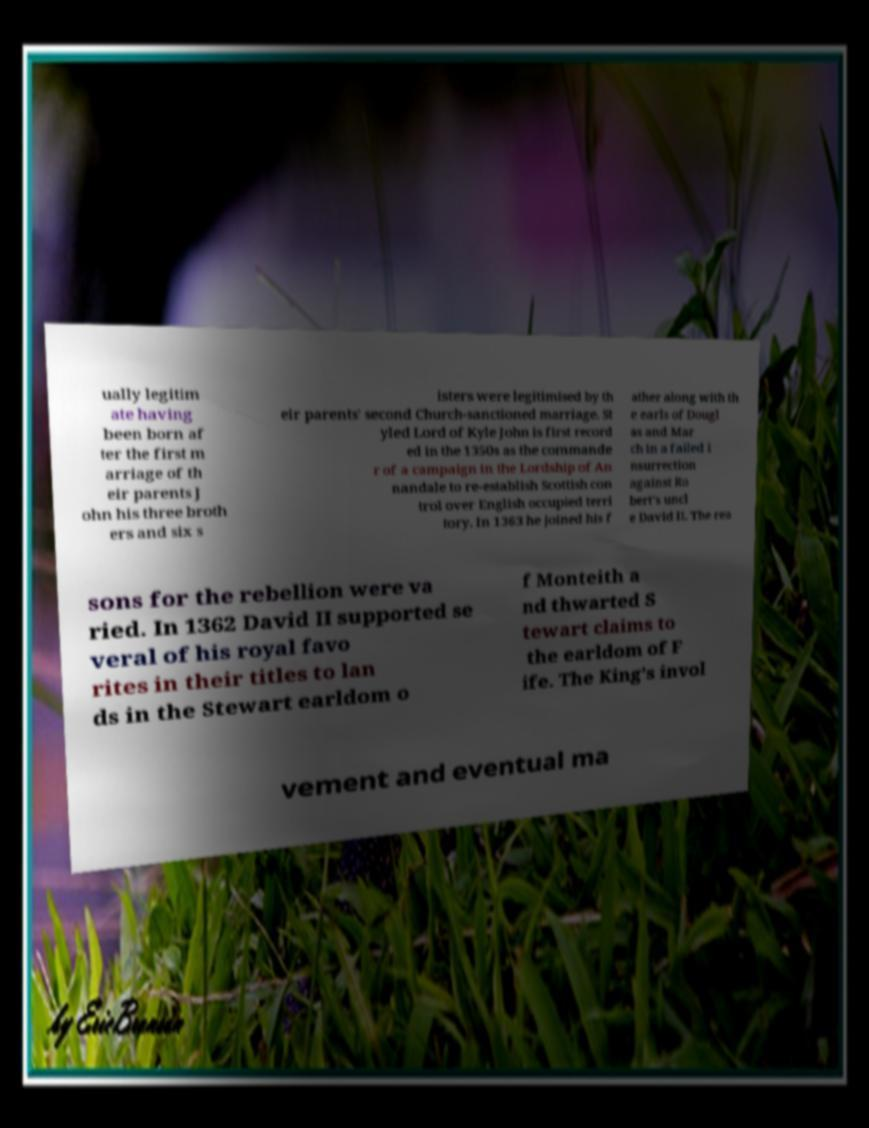There's text embedded in this image that I need extracted. Can you transcribe it verbatim? ually legitim ate having been born af ter the first m arriage of th eir parents J ohn his three broth ers and six s isters were legitimised by th eir parents' second Church-sanctioned marriage. St yled Lord of Kyle John is first record ed in the 1350s as the commande r of a campaign in the Lordship of An nandale to re-establish Scottish con trol over English occupied terri tory. In 1363 he joined his f ather along with th e earls of Dougl as and Mar ch in a failed i nsurrection against Ro bert's uncl e David II. The rea sons for the rebellion were va ried. In 1362 David II supported se veral of his royal favo rites in their titles to lan ds in the Stewart earldom o f Monteith a nd thwarted S tewart claims to the earldom of F ife. The King's invol vement and eventual ma 